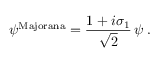<formula> <loc_0><loc_0><loc_500><loc_500>\psi ^ { M a j o r a n a } = \frac { 1 + i \sigma _ { 1 } } { \sqrt { 2 } } \, \psi \, .</formula> 